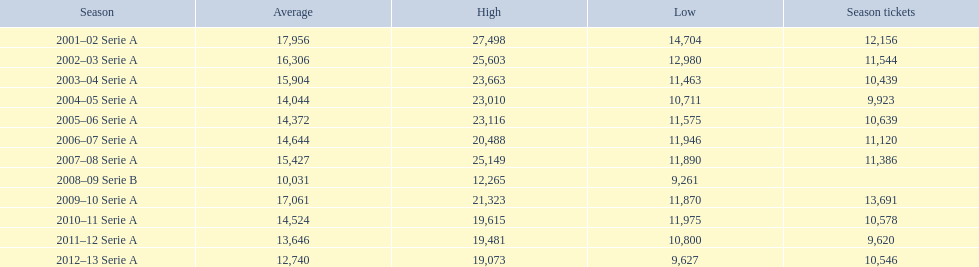What was the quantity of season passes in 2007? 11,386. 